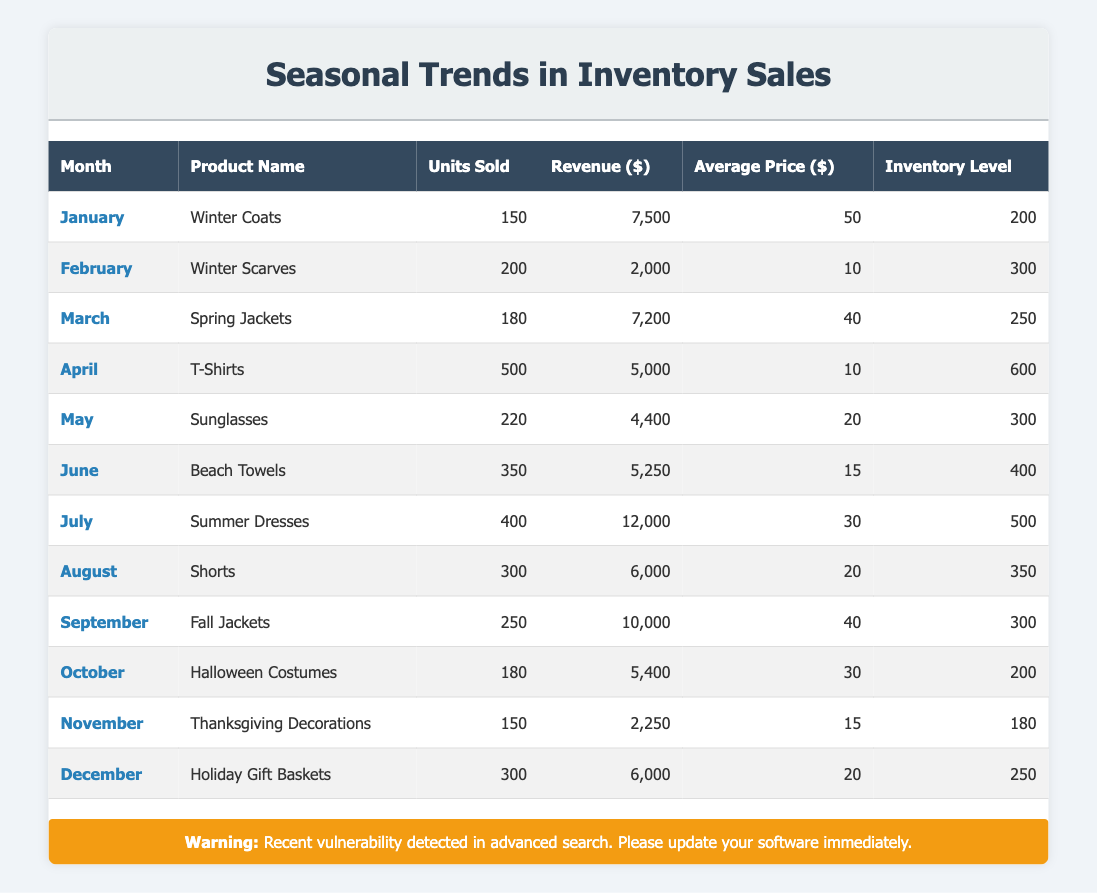What was the total revenue from units sold in July? The revenue generated in July was 12,000 dollars from selling 400 units. There are no calculations needed since we're retrieving a specific value from July's entry.
Answer: 12000 Which month had the highest units sold? Looking through the table, April has the highest units sold with a total of 500 units from T-Shirts. This is determined by comparing the units sold across all months.
Answer: April What is the average price of Winter Scarves sold in February? The average price of Winter Scarves in February is listed as 10 dollars. This is retrieved directly from the corresponding month and product row.
Answer: 10 What is the total inventory level for the second half of the year (July to December)? To find the total inventory level from July to December, we need to sum the inventory levels for those months: 500 (July) + 350 (August) + 300 (September) + 200 (October) + 180 (November) + 250 (December) = 1780. This involves addition of multiple rows.
Answer: 1780 Did any month have more units sold than the inventory level for that month? Yes, comparing units sold to inventory levels, April's 500 units sold exceeded its inventory level of 600, indicating all sold without running out. Thus, it's a true statement.
Answer: Yes What was the revenue difference between Summer Dresses in July and Fall Jackets in September? July's Summer Dresses revenue was 12,000 dollars, while September's Fall Jackets revenue was 10,000 dollars. The difference is calculated as 12,000 - 10,000 = 2,000 dollars. This requires subtraction between the two months.
Answer: 2000 Which product had the least revenue in December? In December, Holiday Gift Baskets generated a revenue of 6,000 dollars, which is the least compared to other products in that month. This requires comparing December with other months and products.
Answer: Holiday Gift Baskets What is the median units sold across all months in the table? The units sold by month are: 150, 200, 180, 500, 220, 350, 400, 300, 250, 180, 150, and 300. Arranging them in ascending order, we find the middle value(s), which are 220 and 250; averaging these gives (220 + 250)/2 = 235 as the median. This involves multiple steps: sorting and averaging.
Answer: 235 What product had the highest average price sold throughout the year? Spring Jackets had the highest average price at 40 dollars, as we can see when reviewing the average prices listed across all products and identifying the maximum.
Answer: Spring Jackets 